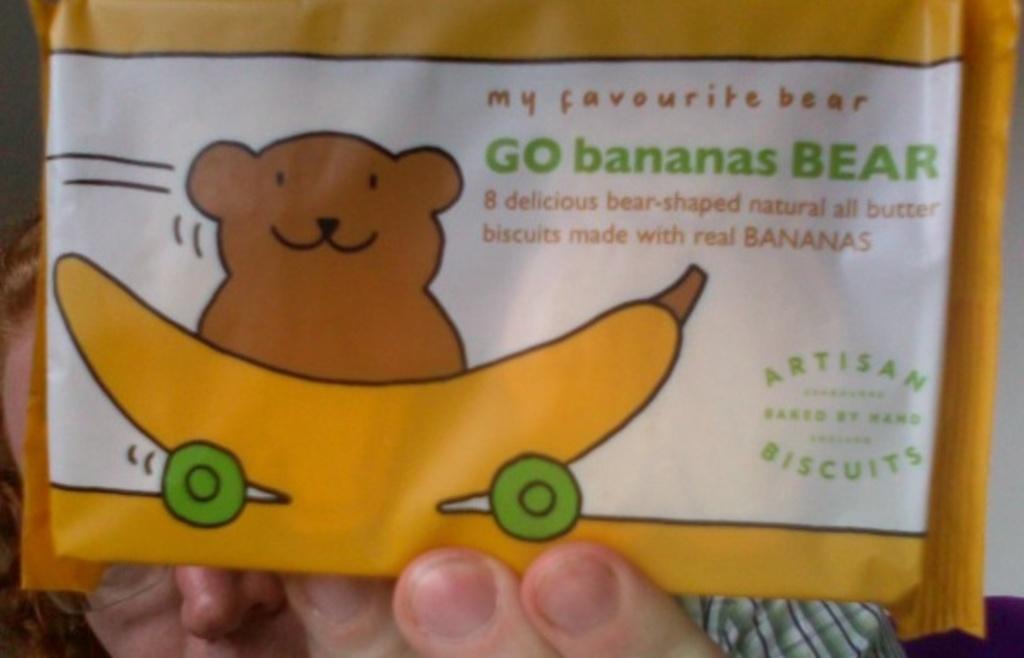Please provide a concise description of this image. At the bottom of the image there is a woman and she is holding a packet with an image of a teddy bear and a banana on it and there is a text on the packet. 